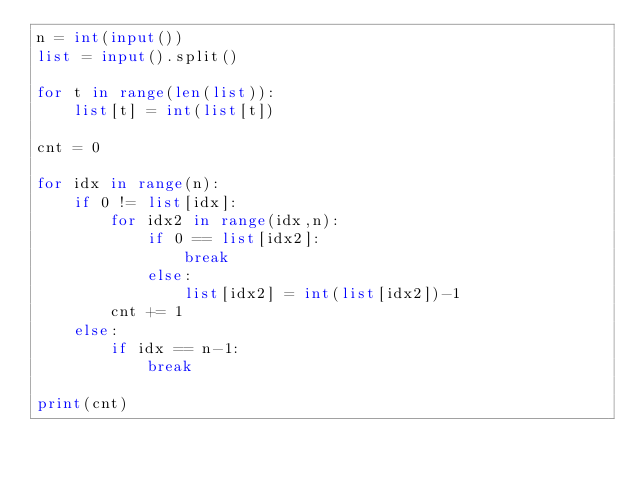<code> <loc_0><loc_0><loc_500><loc_500><_Python_>n = int(input())
list = input().split()

for t in range(len(list)):
    list[t] = int(list[t])

cnt = 0

for idx in range(n):
    if 0 != list[idx]:
        for idx2 in range(idx,n):
            if 0 == list[idx2]:
                break
            else:
                list[idx2] = int(list[idx2])-1
        cnt += 1
    else:
        if idx == n-1:
            break

print(cnt)
</code> 